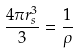Convert formula to latex. <formula><loc_0><loc_0><loc_500><loc_500>\frac { 4 \pi r _ { s } ^ { 3 } } { 3 } = \frac { 1 } { \rho }</formula> 